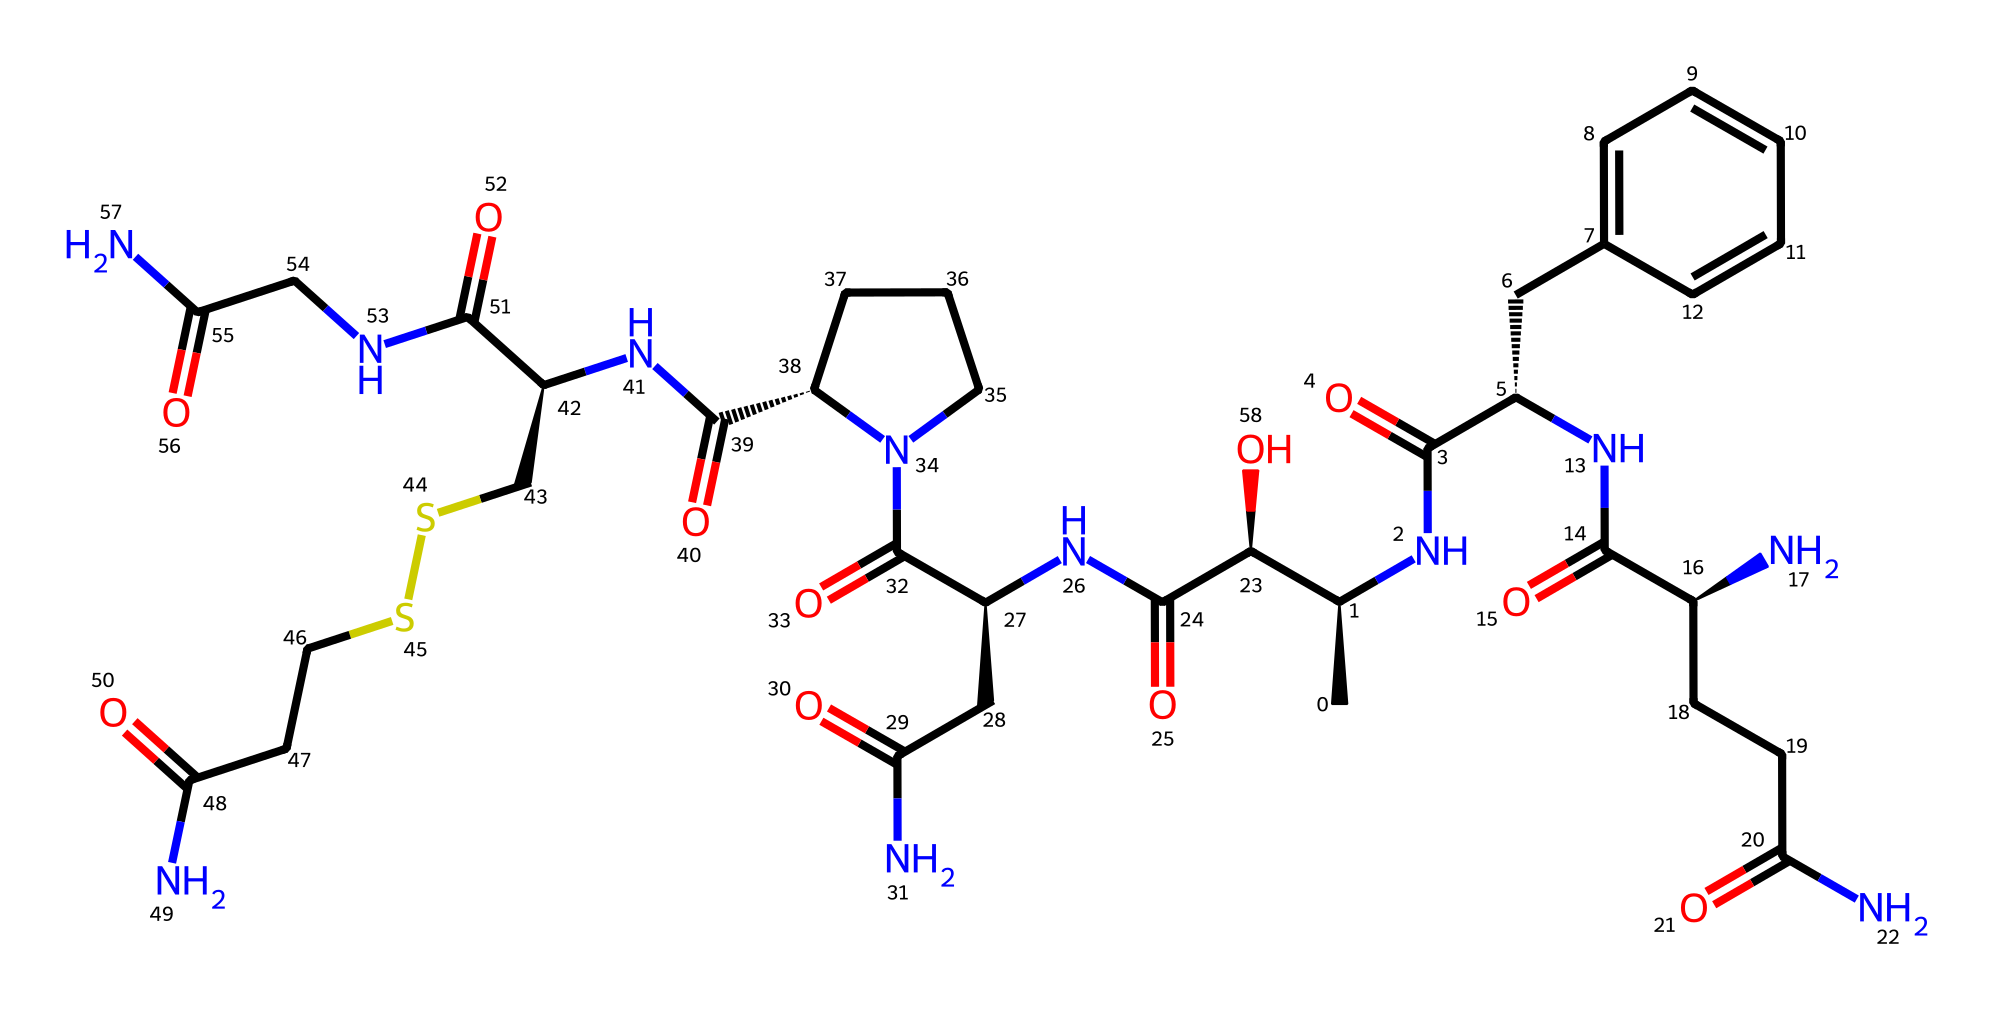What is the molecular formula of oxytocin? To determine the molecular formula from the SMILES representation, we need to count the different types of atoms present. In the chemical, there are multiple carbon (C), oxygen (O), nitrogen (N), and sulfur (S) atoms. The final count yields C43, H66, N12, O12, and S1.
Answer: C43H66N12O12S How many carbon atoms are in oxytocin? By analyzing the SMILES representation, we can count all the carbon atoms represented by "C" symbols. A thorough count shows there are 43 carbon atoms in total.
Answer: 43 What type of molecule is oxytocin? Oxytocin is a peptide hormone, which is evident from its structure that contains multiple amino acids linked by peptide bonds. This classification is common for hormones affecting social and reproductive behaviors.
Answer: peptide hormone Which functional groups are present in oxytocin? To identify functional groups, we examine the structure. There are amides (indicated by the carbonyl group attached to nitrogen), an alcohol (indicated by the hydroxyl -OH), and a thiol (indicated by the presence of S connected to a carbon). This mixture reveals various functional groups.
Answer: amides, alcohol, thiol What is the primary role of oxytocin in the body? The primary role can be understood from its function associated with bonding and social behaviors. Oxytocin is well known as the "bonding hormone" or "love hormone" which is involved in childbirth and social bonding.
Answer: bonding hormone How many nitrogen atoms are in oxytocin? Counting the nitrogen atoms in the structure from the SMILES, we find there are 12 distinct nitrogen atoms represented throughout the molecule.
Answer: 12 What is the significance of the sulfur atom in oxytocin? The sulfur atom present in oxytocin, indicated by "S", plays a crucial role in forming disulfide bonds which help maintain the structural stability and shape of the hormone, ensuring its biological activity.
Answer: structural stability 